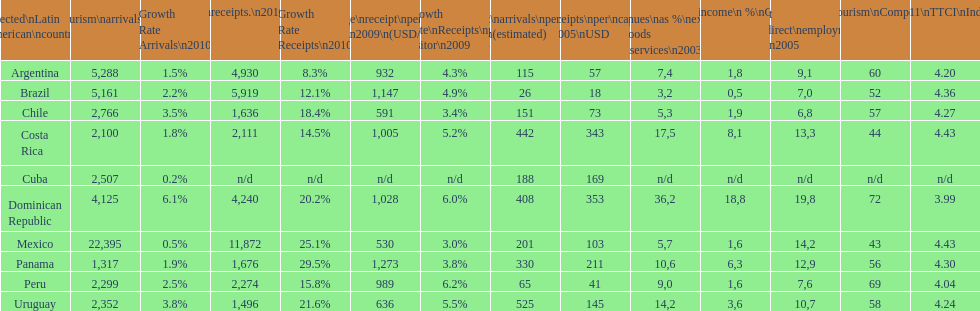In 2003, which nation had the lowest tourism revenue? Brazil. 